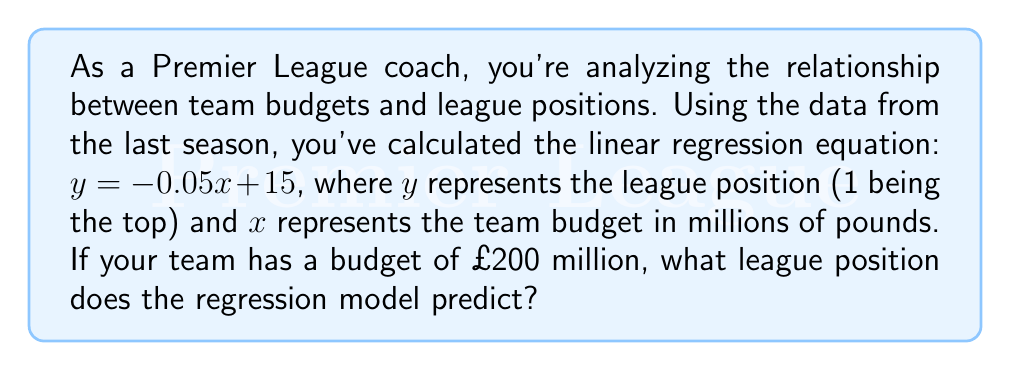Can you answer this question? To solve this problem, we'll follow these steps:

1. Understand the given regression equation:
   $y = -0.05x + 15$
   Where:
   $y$ = predicted league position
   $x$ = team budget in millions of pounds

2. Insert the given budget into the equation:
   $x = 200$ (million pounds)

3. Calculate the predicted league position:
   $y = -0.05(200) + 15$
   $y = -10 + 15$
   $y = 5$

4. Interpret the result:
   The regression model predicts a league position of 5 for a team with a £200 million budget.

Note: Since league positions are whole numbers, we round to the nearest integer if necessary. In this case, 5 is already a whole number.
Answer: 5 